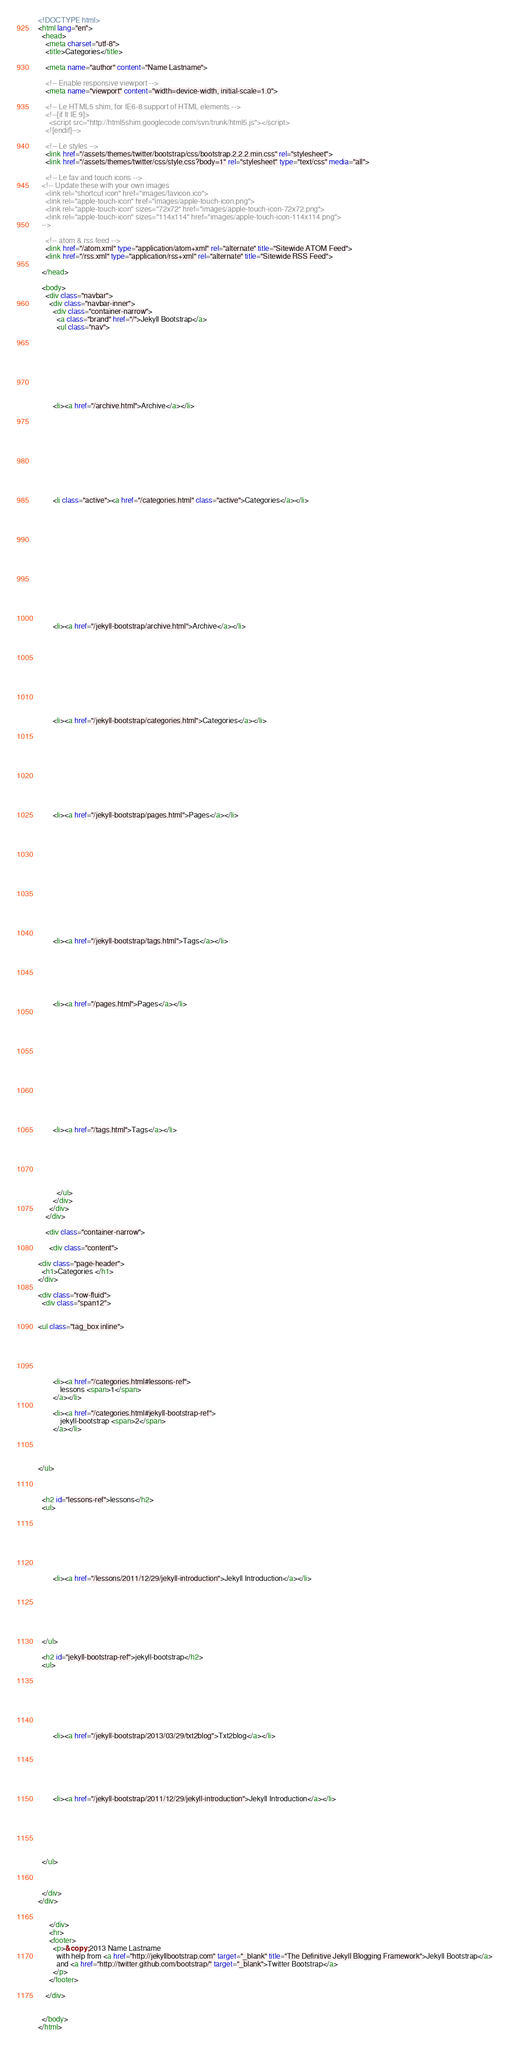<code> <loc_0><loc_0><loc_500><loc_500><_HTML_>
<!DOCTYPE html>
<html lang="en">
  <head>
    <meta charset="utf-8">
    <title>Categories</title>
    
    <meta name="author" content="Name Lastname">

    <!-- Enable responsive viewport -->
    <meta name="viewport" content="width=device-width, initial-scale=1.0">

    <!-- Le HTML5 shim, for IE6-8 support of HTML elements -->
    <!--[if lt IE 9]>
      <script src="http://html5shim.googlecode.com/svn/trunk/html5.js"></script>
    <![endif]-->

    <!-- Le styles -->
    <link href="/assets/themes/twitter/bootstrap/css/bootstrap.2.2.2.min.css" rel="stylesheet">
    <link href="/assets/themes/twitter/css/style.css?body=1" rel="stylesheet" type="text/css" media="all">

    <!-- Le fav and touch icons -->
  <!-- Update these with your own images
    <link rel="shortcut icon" href="images/favicon.ico">
    <link rel="apple-touch-icon" href="images/apple-touch-icon.png">
    <link rel="apple-touch-icon" sizes="72x72" href="images/apple-touch-icon-72x72.png">
    <link rel="apple-touch-icon" sizes="114x114" href="images/apple-touch-icon-114x114.png">
  -->

    <!-- atom & rss feed -->
    <link href="/atom.xml" type="application/atom+xml" rel="alternate" title="Sitewide ATOM Feed">
    <link href="/rss.xml" type="application/rss+xml" rel="alternate" title="Sitewide RSS Feed">

  </head>

  <body>
    <div class="navbar">
      <div class="navbar-inner">
        <div class="container-narrow">
          <a class="brand" href="/">Jekyll Bootstrap</a>
          <ul class="nav">
            
            
            


  
    
      
      	
      	<li><a href="/archive.html">Archive</a></li>
      	
      
    
  
    
      
    
  
    
      
      	
      	<li class="active"><a href="/categories.html" class="active">Categories</a></li>
      	
      
    
  
    
      
    
  
    
      
    
  
    
      
      	
      	<li><a href="/jekyll-bootstrap/archive.html">Archive</a></li>
      	
      
    
  
    
      
    
  
    
      
      	
      	<li><a href="/jekyll-bootstrap/categories.html">Categories</a></li>
      	
      
    
  
    
      
    
  
    
      
      	
      	<li><a href="/jekyll-bootstrap/pages.html">Pages</a></li>
      	
      
    
  
    
      
    
  
    
      
    
  
    
      
      	
      	<li><a href="/jekyll-bootstrap/tags.html">Tags</a></li>
      	
      
    
  
    
      
      	
      	<li><a href="/pages.html">Pages</a></li>
      	
      
    
  
    
      
    
  
    
      
    
  
    
      
      	
      	<li><a href="/tags.html">Tags</a></li>
      	
      
    
  



          </ul>
        </div>
      </div>
    </div>

    <div class="container-narrow">

      <div class="content">
        
<div class="page-header">
  <h1>Categories </h1>
</div>

<div class="row-fluid">
  <div class="span12">
    

<ul class="tag_box inline">
  
  


  
     
    	<li><a href="/categories.html#lessons-ref">
    		lessons <span>1</span>
    	</a></li>
     
    	<li><a href="/categories.html#jekyll-bootstrap-ref">
    		jekyll-bootstrap <span>2</span>
    	</a></li>
    
  


</ul>


 
  <h2 id="lessons-ref">lessons</h2>
  <ul>
      
    


  
    
      
      	
      	<li><a href="/lessons/2011/12/29/jekyll-introduction">Jekyll Introduction</a></li>
      	
      
    
  



  </ul>
 
  <h2 id="jekyll-bootstrap-ref">jekyll-bootstrap</h2>
  <ul>
      
    


  
    
      
      	
      	<li><a href="/jekyll-bootstrap/2013/03/29/txt2blog">Txt2blog</a></li>
      	
      
    
  
    
      
      	
      	<li><a href="/jekyll-bootstrap/2011/12/29/jekyll-introduction">Jekyll Introduction</a></li>
      	
      
    
  



  </ul>



  </div>
</div>


      </div>
      <hr>
      <footer>
        <p>&copy; 2013 Name Lastname
          with help from <a href="http://jekyllbootstrap.com" target="_blank" title="The Definitive Jekyll Blogging Framework">Jekyll Bootstrap</a>
          and <a href="http://twitter.github.com/bootstrap/" target="_blank">Twitter Bootstrap</a>
        </p>
      </footer>

    </div>

    
  </body>
</html>

</code> 